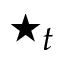Convert formula to latex. <formula><loc_0><loc_0><loc_500><loc_500>^ { * } _ { t }</formula> 